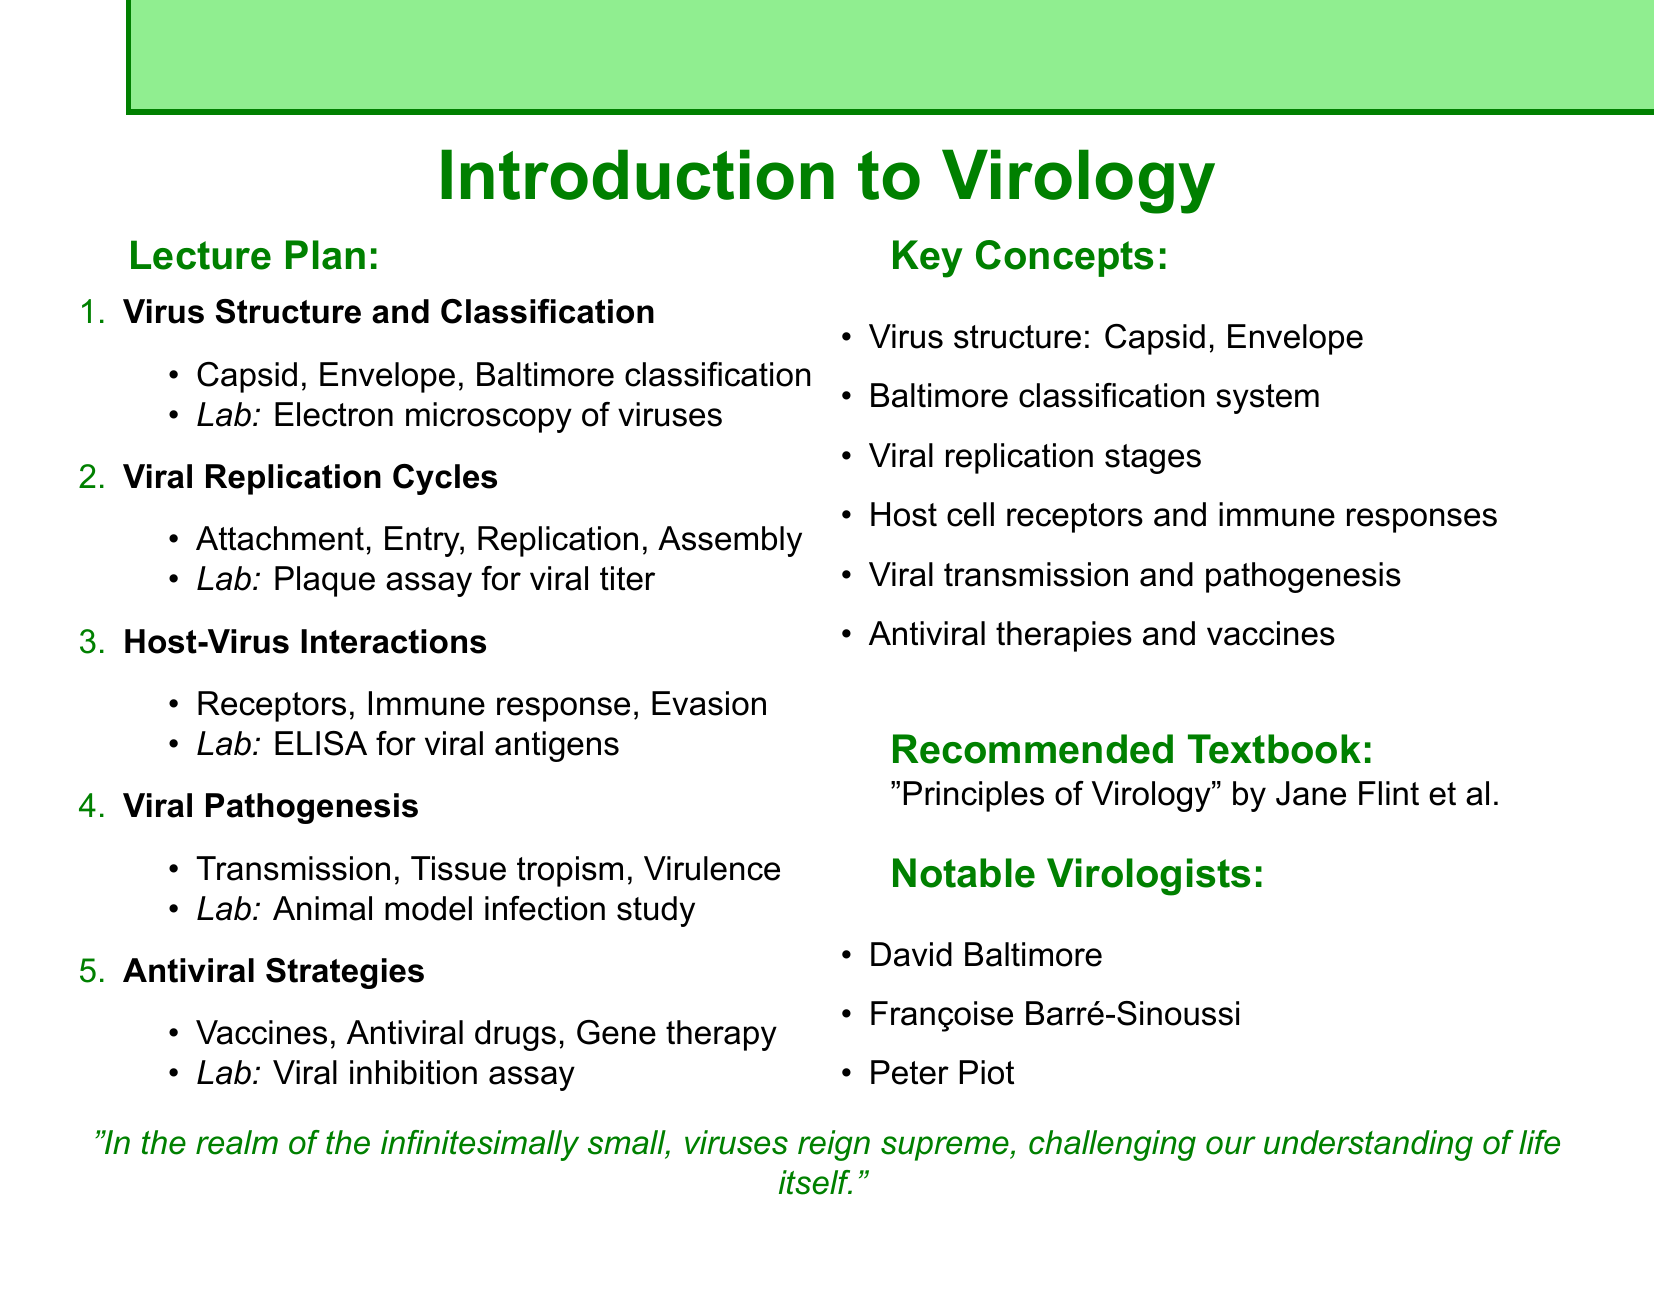What is the course title? The course title is prominently displayed at the beginning of the document.
Answer: Introduction to Virology What week covers Viral Pathogenesis? Each week is clearly numbered, and the topics are listed sequentially in the lecture plan.
Answer: Week 4 Name one key concept from the topic on Viral Replication Cycles. Key concepts are listed under each week's topic. One such concept is mentioned for the replication cycle.
Answer: Genome replication What experiment is associated with Host-Virus Interactions? Each week's lecture plan includes a corresponding experiment listed under it.
Answer: ELISA to detect viral antigens Who is one of the notable virologists mentioned? Notable virologists are listed in a dedicated section towards the end of the document.
Answer: David Baltimore What is the recommended textbook for the course? A specific section in the document clearly mentions the textbook recommended for students.
Answer: Principles of Virology by Jane Flint et al List one antiviral strategy discussed in the course. Under the Antiviral Strategies topic, key concepts are provided, which can be directly listed.
Answer: Vaccines How many weeks are planned for this course? The document outlines the structure of the course across various weeks.
Answer: 5 